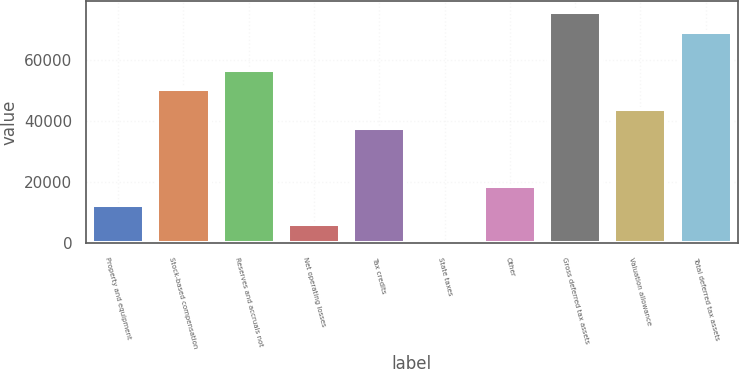Convert chart to OTSL. <chart><loc_0><loc_0><loc_500><loc_500><bar_chart><fcel>Property and equipment<fcel>Stock-based compensation<fcel>Reserves and accruals not<fcel>Net operating losses<fcel>Tax credits<fcel>State taxes<fcel>Other<fcel>Gross deferred tax assets<fcel>Valuation allowance<fcel>Total deferred tax assets<nl><fcel>12579.4<fcel>50290.6<fcel>56575.8<fcel>6294.2<fcel>37720.2<fcel>9<fcel>18864.6<fcel>75431.4<fcel>44005.4<fcel>69146.2<nl></chart> 